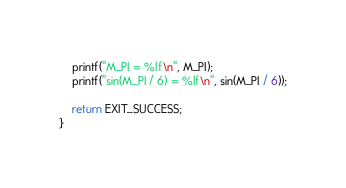Convert code to text. <code><loc_0><loc_0><loc_500><loc_500><_C_>    printf("M_PI = %lf\n", M_PI);
    printf("sin(M_PI / 6) = %lf\n", sin(M_PI / 6));

    return EXIT_SUCCESS;
}</code> 